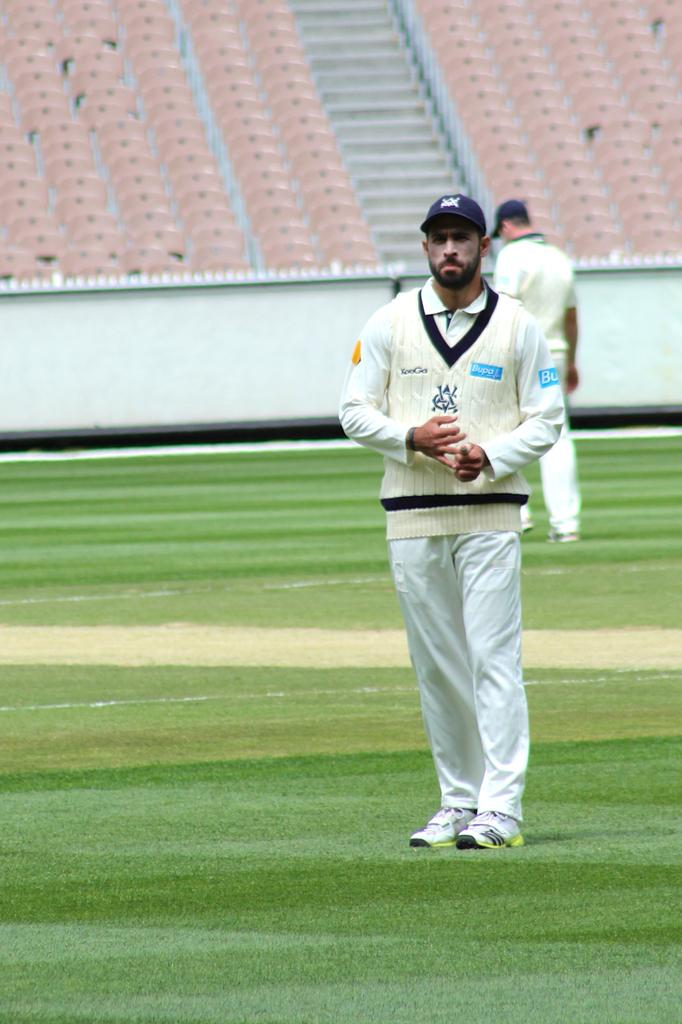<image>
Relay a brief, clear account of the picture shown. a man wearing a sweater that said 'bupa' on it 